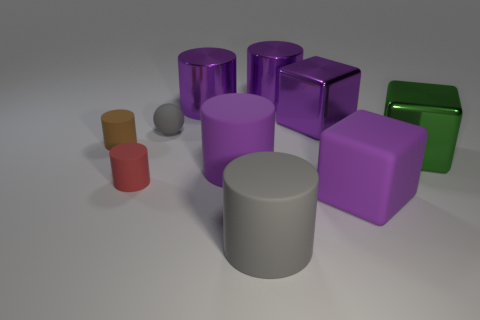There is a big object that is in front of the tiny red matte cylinder and right of the big gray cylinder; what shape is it?
Keep it short and to the point. Cube. There is a tiny rubber thing to the right of the red matte cylinder; what color is it?
Provide a succinct answer. Gray. What size is the cube that is both in front of the small gray rubber object and on the left side of the big green cube?
Offer a very short reply. Large. Is the big gray thing made of the same material as the purple cylinder in front of the green shiny cube?
Offer a very short reply. Yes. What number of big metallic things have the same shape as the tiny gray thing?
Your answer should be very brief. 0. What material is the other cube that is the same color as the rubber cube?
Provide a short and direct response. Metal. What number of large gray matte objects are there?
Your response must be concise. 1. Is the shape of the small brown object the same as the gray matte thing that is in front of the gray matte ball?
Your answer should be compact. Yes. What number of objects are big purple rubber things or big metallic objects on the left side of the gray rubber cylinder?
Offer a very short reply. 3. What is the material of the big gray thing that is the same shape as the tiny brown matte object?
Keep it short and to the point. Rubber. 